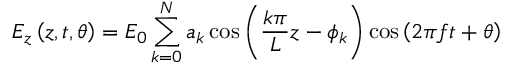Convert formula to latex. <formula><loc_0><loc_0><loc_500><loc_500>E _ { z } \left ( z , t , \theta \right ) = E _ { 0 } \sum _ { k = 0 } ^ { N } a _ { k } \cos \left ( \frac { k \pi } { L } z - \phi _ { k } \right ) \cos \left ( 2 \pi f t + \theta \right )</formula> 